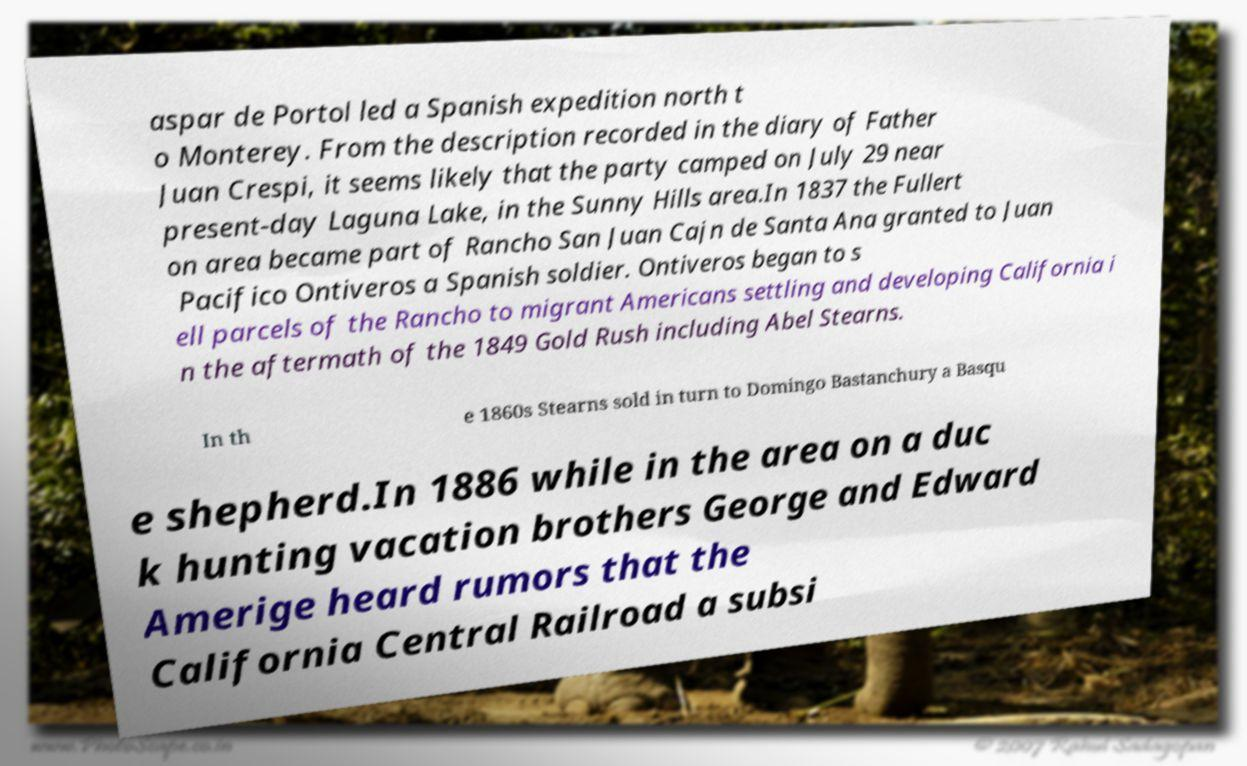Could you extract and type out the text from this image? aspar de Portol led a Spanish expedition north t o Monterey. From the description recorded in the diary of Father Juan Crespi, it seems likely that the party camped on July 29 near present-day Laguna Lake, in the Sunny Hills area.In 1837 the Fullert on area became part of Rancho San Juan Cajn de Santa Ana granted to Juan Pacifico Ontiveros a Spanish soldier. Ontiveros began to s ell parcels of the Rancho to migrant Americans settling and developing California i n the aftermath of the 1849 Gold Rush including Abel Stearns. In th e 1860s Stearns sold in turn to Domingo Bastanchury a Basqu e shepherd.In 1886 while in the area on a duc k hunting vacation brothers George and Edward Amerige heard rumors that the California Central Railroad a subsi 